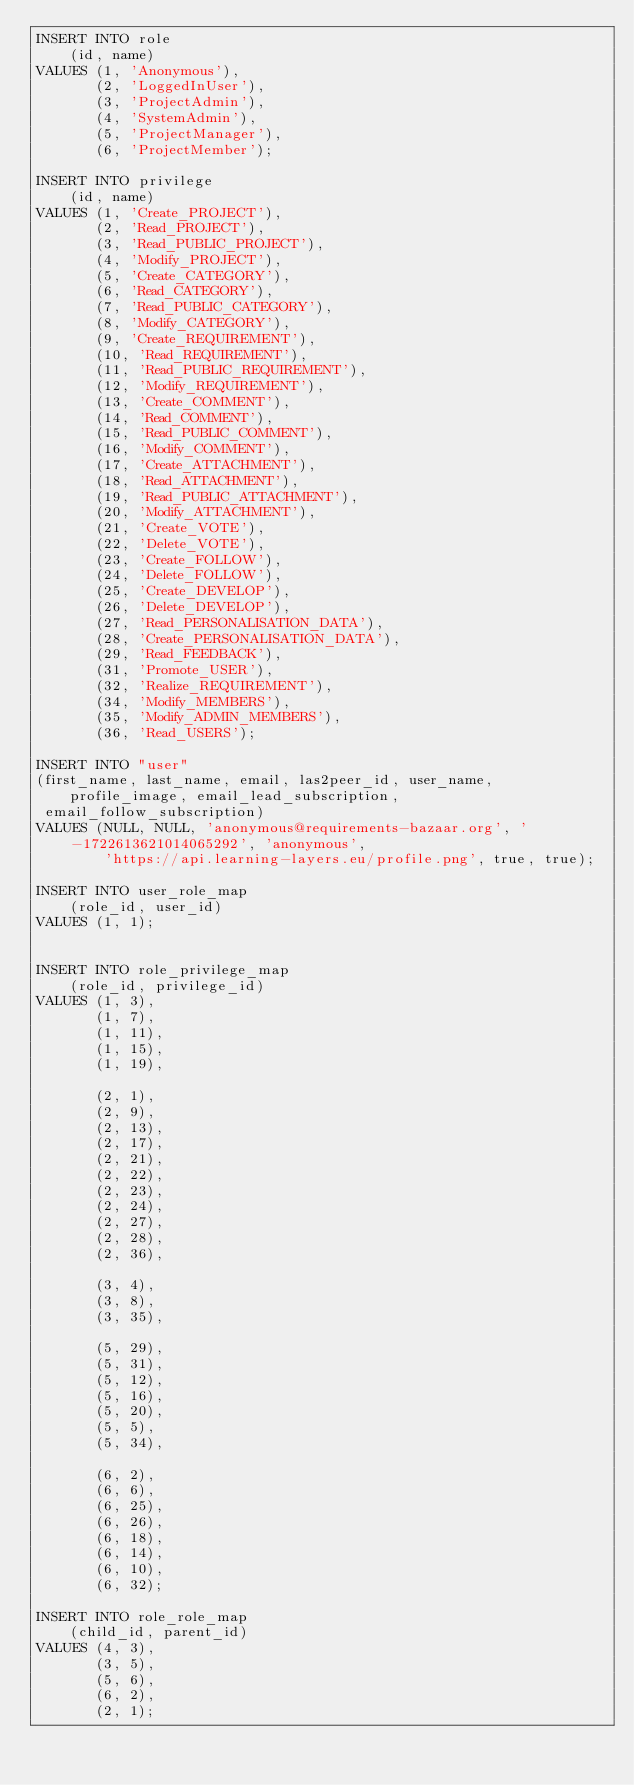<code> <loc_0><loc_0><loc_500><loc_500><_SQL_>INSERT INTO role
    (id, name)
VALUES (1, 'Anonymous'),
       (2, 'LoggedInUser'),
       (3, 'ProjectAdmin'),
       (4, 'SystemAdmin'),
       (5, 'ProjectManager'),
       (6, 'ProjectMember');

INSERT INTO privilege
    (id, name)
VALUES (1, 'Create_PROJECT'),
       (2, 'Read_PROJECT'),
       (3, 'Read_PUBLIC_PROJECT'),
       (4, 'Modify_PROJECT'),
       (5, 'Create_CATEGORY'),
       (6, 'Read_CATEGORY'),
       (7, 'Read_PUBLIC_CATEGORY'),
       (8, 'Modify_CATEGORY'),
       (9, 'Create_REQUIREMENT'),
       (10, 'Read_REQUIREMENT'),
       (11, 'Read_PUBLIC_REQUIREMENT'),
       (12, 'Modify_REQUIREMENT'),
       (13, 'Create_COMMENT'),
       (14, 'Read_COMMENT'),
       (15, 'Read_PUBLIC_COMMENT'),
       (16, 'Modify_COMMENT'),
       (17, 'Create_ATTACHMENT'),
       (18, 'Read_ATTACHMENT'),
       (19, 'Read_PUBLIC_ATTACHMENT'),
       (20, 'Modify_ATTACHMENT'),
       (21, 'Create_VOTE'),
       (22, 'Delete_VOTE'),
       (23, 'Create_FOLLOW'),
       (24, 'Delete_FOLLOW'),
       (25, 'Create_DEVELOP'),
       (26, 'Delete_DEVELOP'),
       (27, 'Read_PERSONALISATION_DATA'),
       (28, 'Create_PERSONALISATION_DATA'),
       (29, 'Read_FEEDBACK'),
       (31, 'Promote_USER'),
       (32, 'Realize_REQUIREMENT'),
       (34, 'Modify_MEMBERS'),
       (35, 'Modify_ADMIN_MEMBERS'),
       (36, 'Read_USERS');

INSERT INTO "user"
(first_name, last_name, email, las2peer_id, user_name, profile_image, email_lead_subscription,
 email_follow_subscription)
VALUES (NULL, NULL, 'anonymous@requirements-bazaar.org', '-1722613621014065292', 'anonymous',
        'https://api.learning-layers.eu/profile.png', true, true);

INSERT INTO user_role_map
    (role_id, user_id)
VALUES (1, 1);


INSERT INTO role_privilege_map
    (role_id, privilege_id)
VALUES (1, 3),
       (1, 7),
       (1, 11),
       (1, 15),
       (1, 19),

       (2, 1),
       (2, 9),
       (2, 13),
       (2, 17),
       (2, 21),
       (2, 22),
       (2, 23),
       (2, 24),
       (2, 27),
       (2, 28),
       (2, 36),

       (3, 4),
       (3, 8),
       (3, 35),

       (5, 29),
       (5, 31),
       (5, 12),
       (5, 16),
       (5, 20),
       (5, 5),
       (5, 34),

       (6, 2),
       (6, 6),
       (6, 25),
       (6, 26),
       (6, 18),
       (6, 14),
       (6, 10),
       (6, 32);

INSERT INTO role_role_map
    (child_id, parent_id)
VALUES (4, 3),
       (3, 5),
       (5, 6),
       (6, 2),
       (2, 1);
</code> 